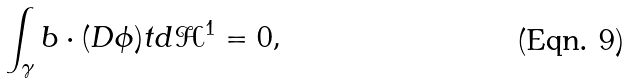<formula> <loc_0><loc_0><loc_500><loc_500>\int _ { \gamma } b \cdot ( D \phi ) t d \mathcal { H } ^ { 1 } = 0 ,</formula> 